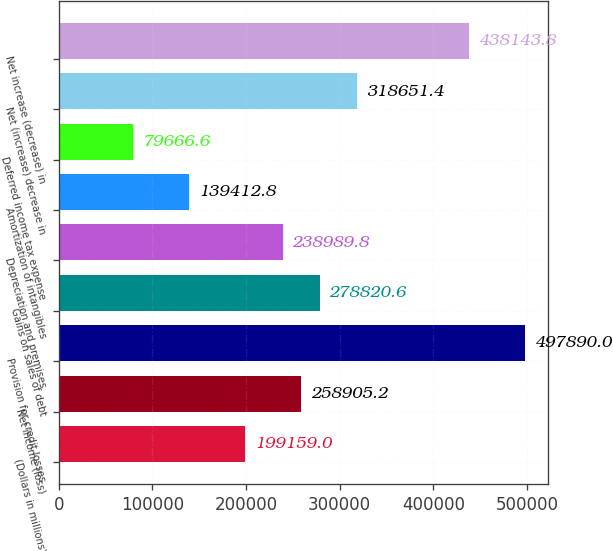Convert chart. <chart><loc_0><loc_0><loc_500><loc_500><bar_chart><fcel>(Dollars in millions)<fcel>Net income (loss)<fcel>Provision for credit losses<fcel>Gains on sales of debt<fcel>Depreciation and premises<fcel>Amortization of intangibles<fcel>Deferred income tax expense<fcel>Net (increase) decrease in<fcel>Net increase (decrease) in<nl><fcel>199159<fcel>258905<fcel>497890<fcel>278821<fcel>238990<fcel>139413<fcel>79666.6<fcel>318651<fcel>438144<nl></chart> 